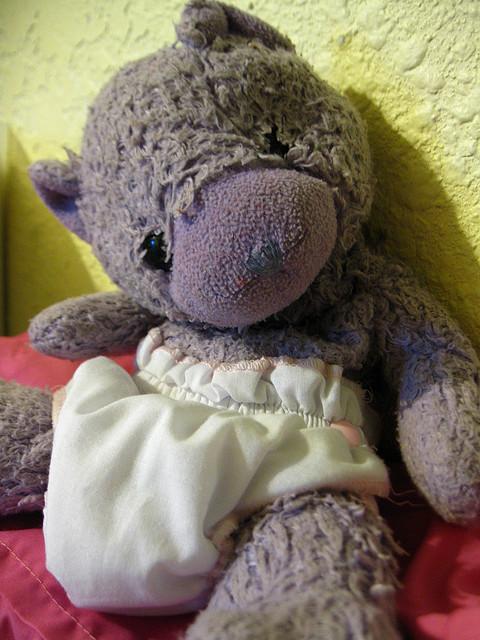Is this bear brand new?
Concise answer only. No. What color is the bear?
Answer briefly. Gray. Is this bear dressed?
Give a very brief answer. Yes. 